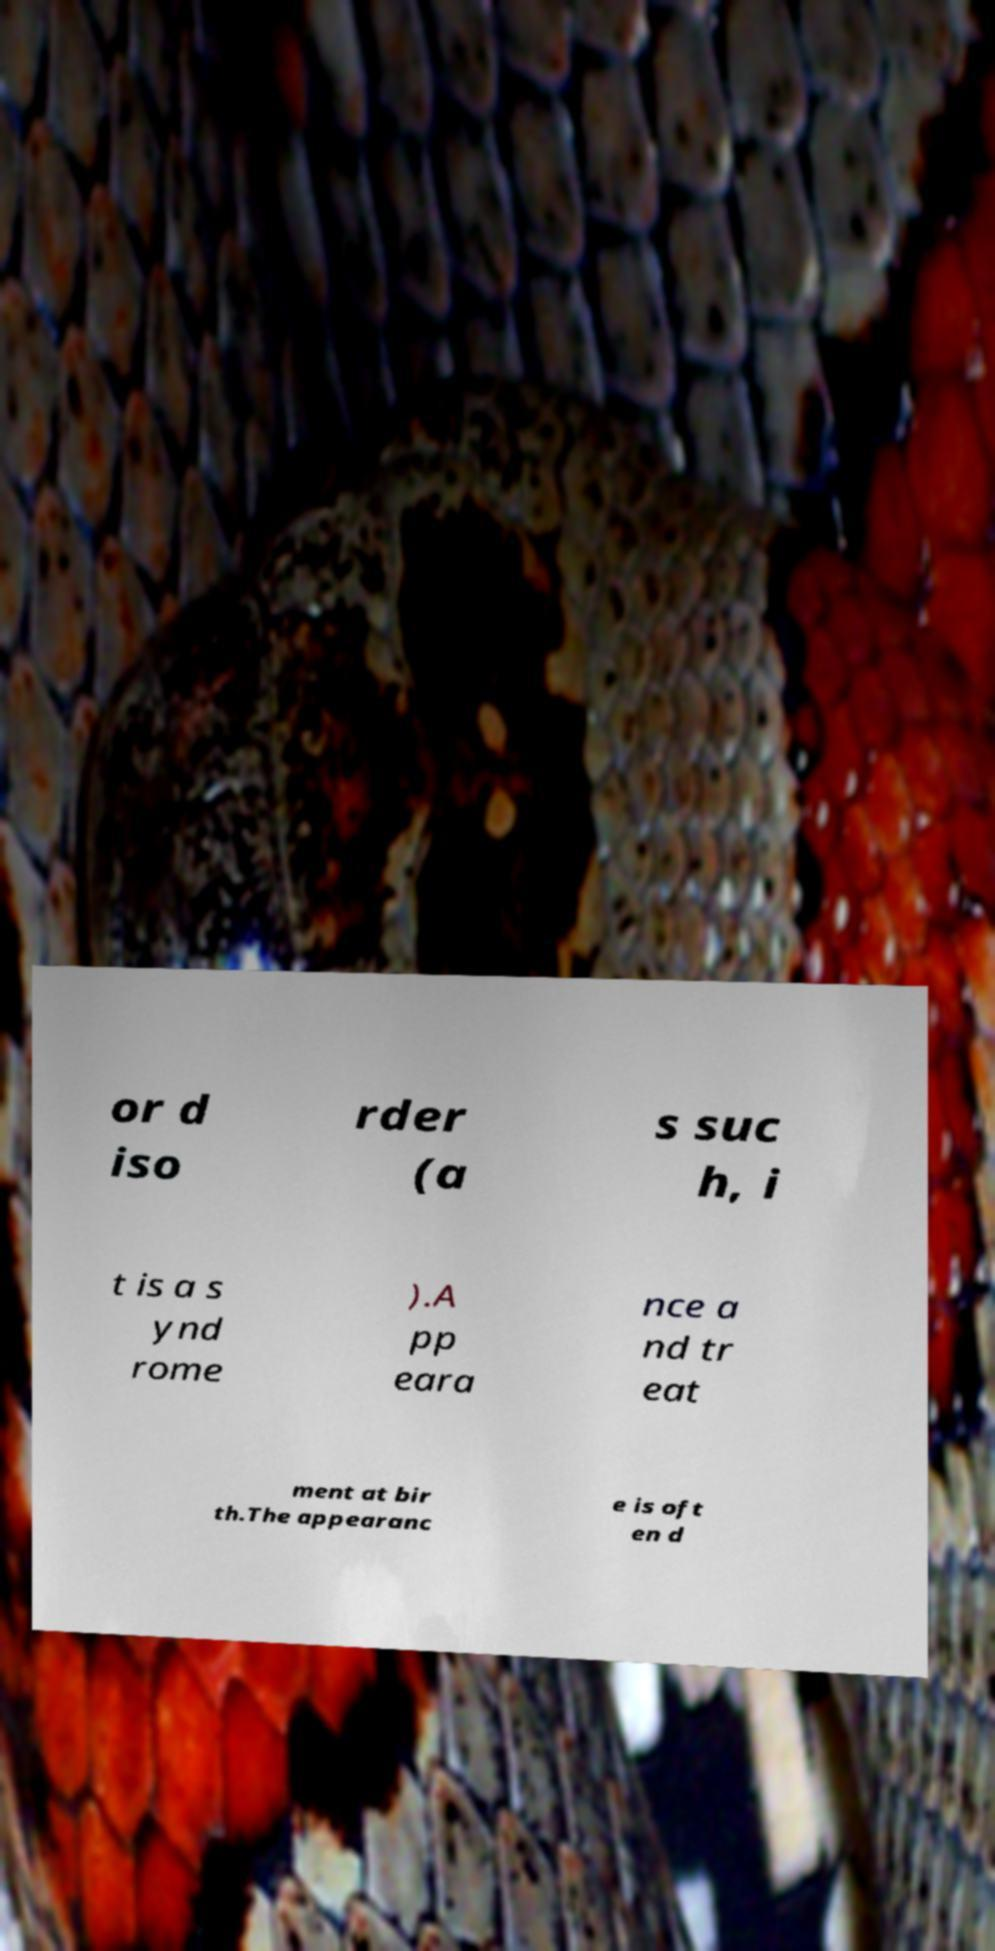Please identify and transcribe the text found in this image. or d iso rder (a s suc h, i t is a s ynd rome ).A pp eara nce a nd tr eat ment at bir th.The appearanc e is oft en d 